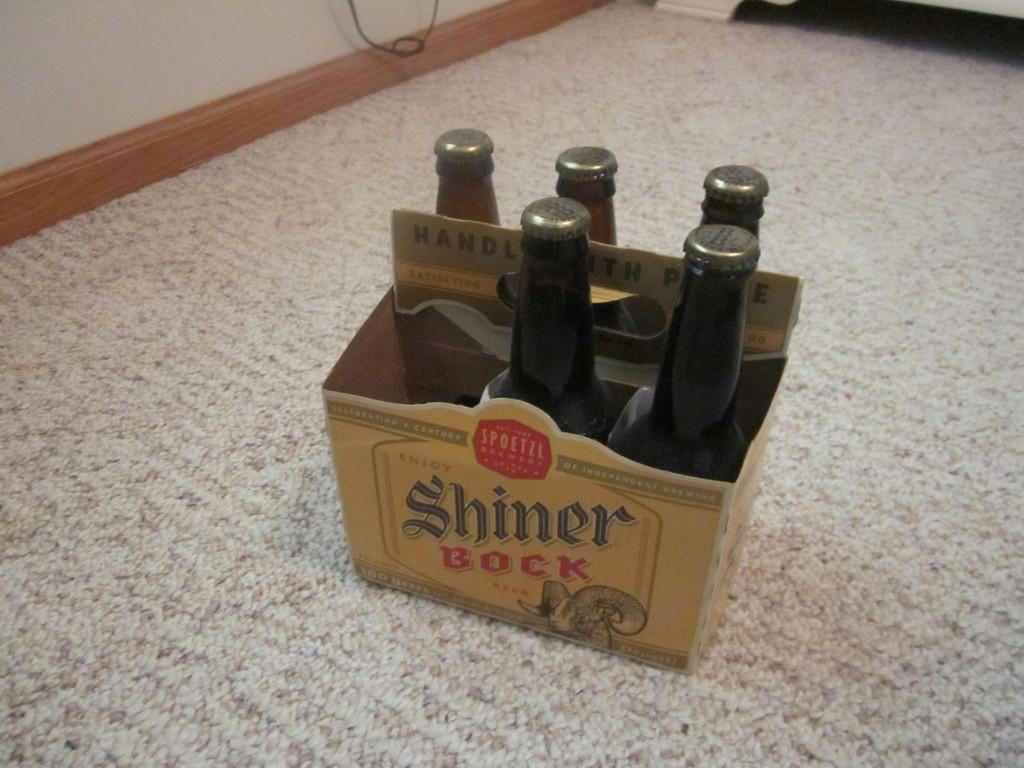<image>
Present a compact description of the photo's key features. A six pack of Shiner Bock beer is missing one of its bottles. 